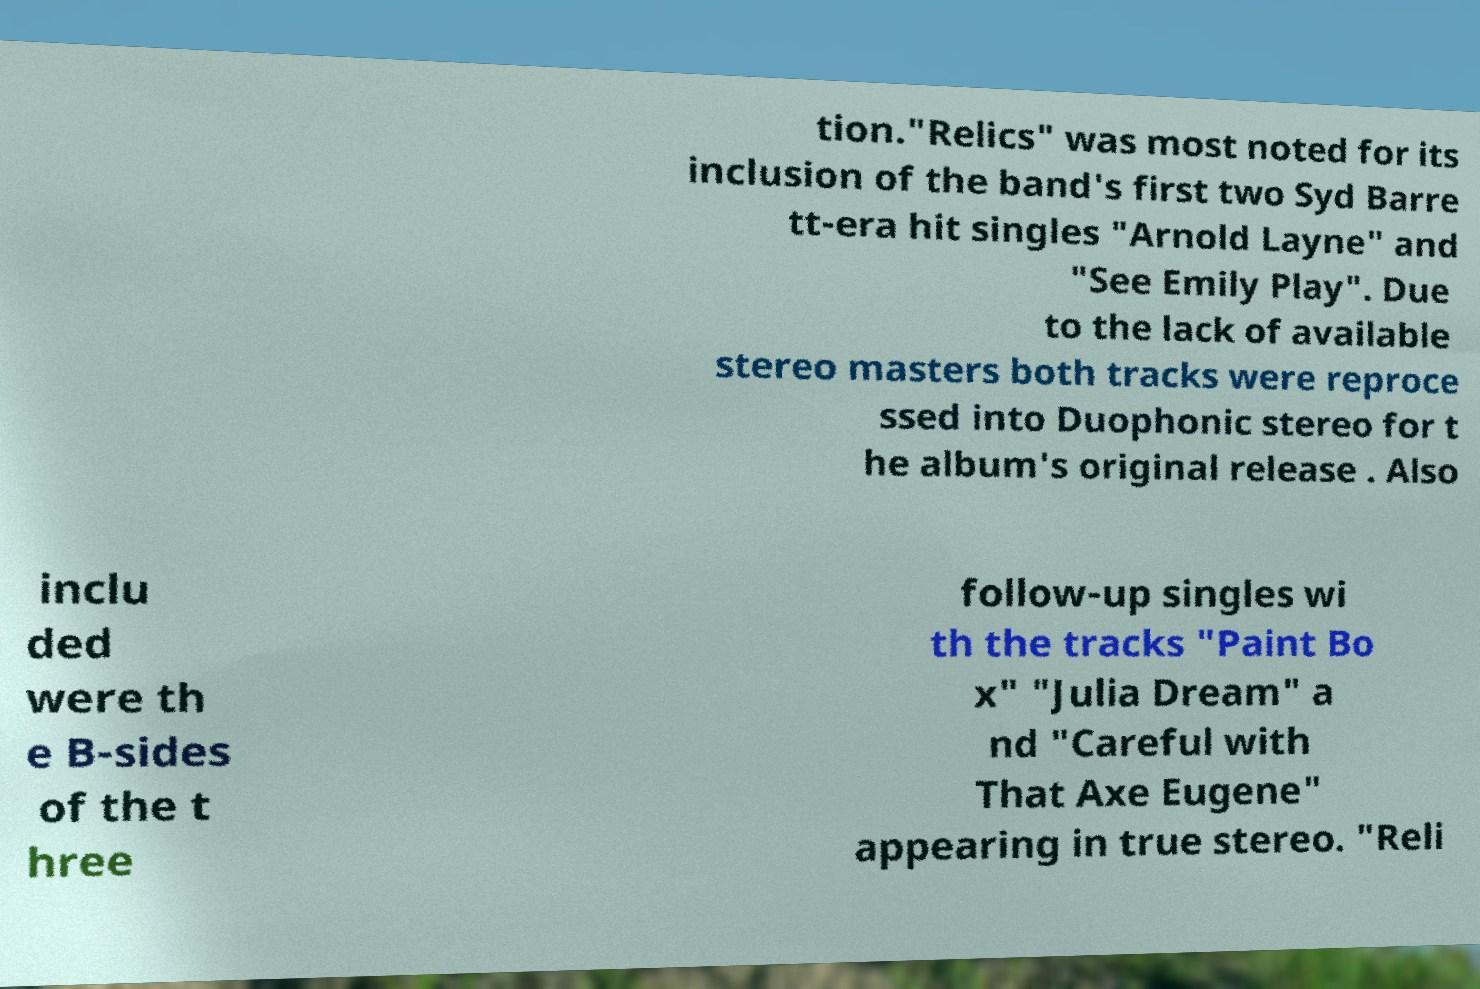Please identify and transcribe the text found in this image. tion."Relics" was most noted for its inclusion of the band's first two Syd Barre tt-era hit singles "Arnold Layne" and "See Emily Play". Due to the lack of available stereo masters both tracks were reproce ssed into Duophonic stereo for t he album's original release . Also inclu ded were th e B-sides of the t hree follow-up singles wi th the tracks "Paint Bo x" "Julia Dream" a nd "Careful with That Axe Eugene" appearing in true stereo. "Reli 